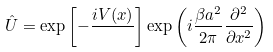<formula> <loc_0><loc_0><loc_500><loc_500>\hat { U } = \exp \left [ - \frac { i V ( x ) } { } \right ] \exp \left ( i \frac { \beta a ^ { 2 } } { 2 \pi } \frac { \partial ^ { 2 } } { \partial x ^ { 2 } } \right )</formula> 